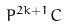Convert formula to latex. <formula><loc_0><loc_0><loc_500><loc_500>P ^ { 2 k + 1 } C</formula> 